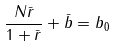<formula> <loc_0><loc_0><loc_500><loc_500>\frac { N \bar { r } } { 1 + \bar { r } } + \bar { b } = b _ { 0 }</formula> 